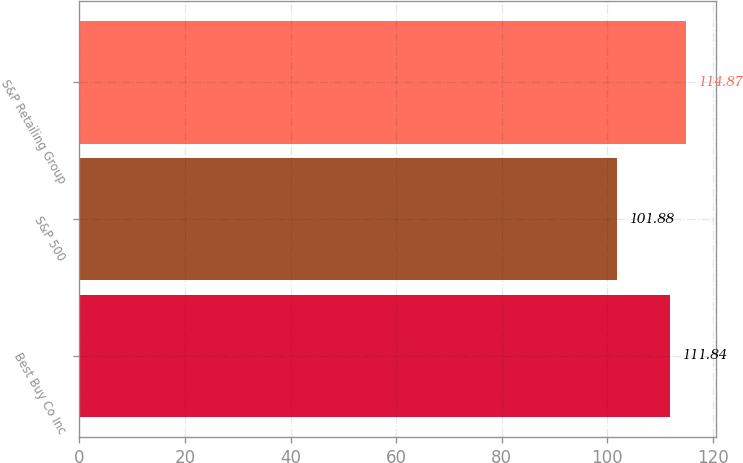<chart> <loc_0><loc_0><loc_500><loc_500><bar_chart><fcel>Best Buy Co Inc<fcel>S&P 500<fcel>S&P Retailing Group<nl><fcel>111.84<fcel>101.88<fcel>114.87<nl></chart> 